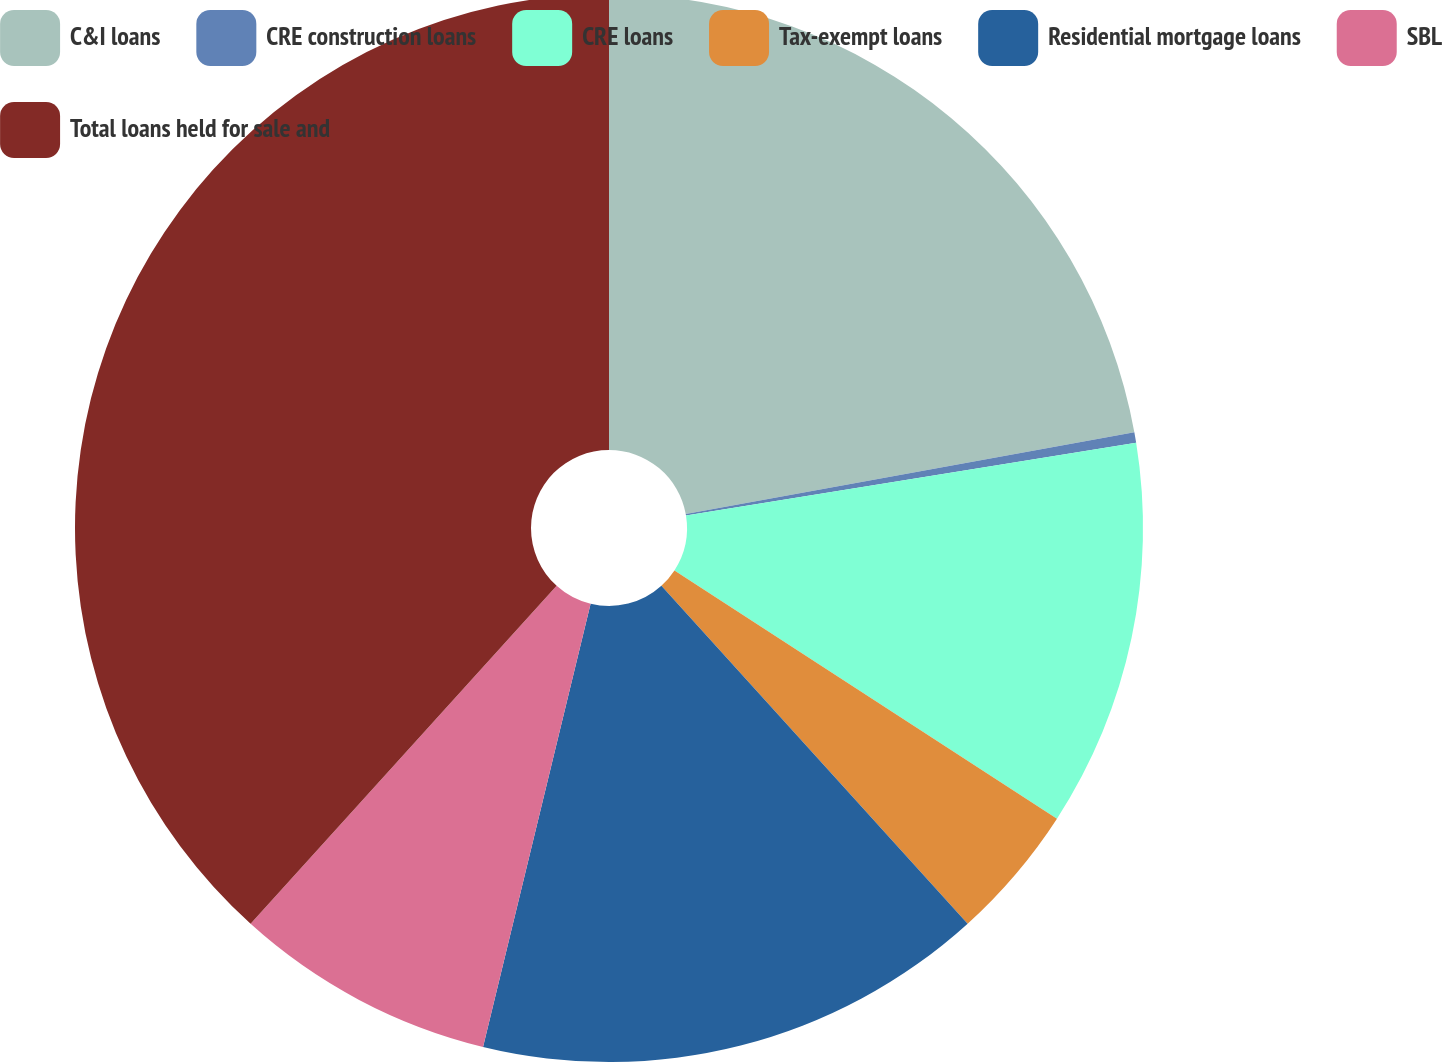<chart> <loc_0><loc_0><loc_500><loc_500><pie_chart><fcel>C&I loans<fcel>CRE construction loans<fcel>CRE loans<fcel>Tax-exempt loans<fcel>Residential mortgage loans<fcel>SBL<fcel>Total loans held for sale and<nl><fcel>22.13%<fcel>0.32%<fcel>11.71%<fcel>4.12%<fcel>15.51%<fcel>7.92%<fcel>38.29%<nl></chart> 